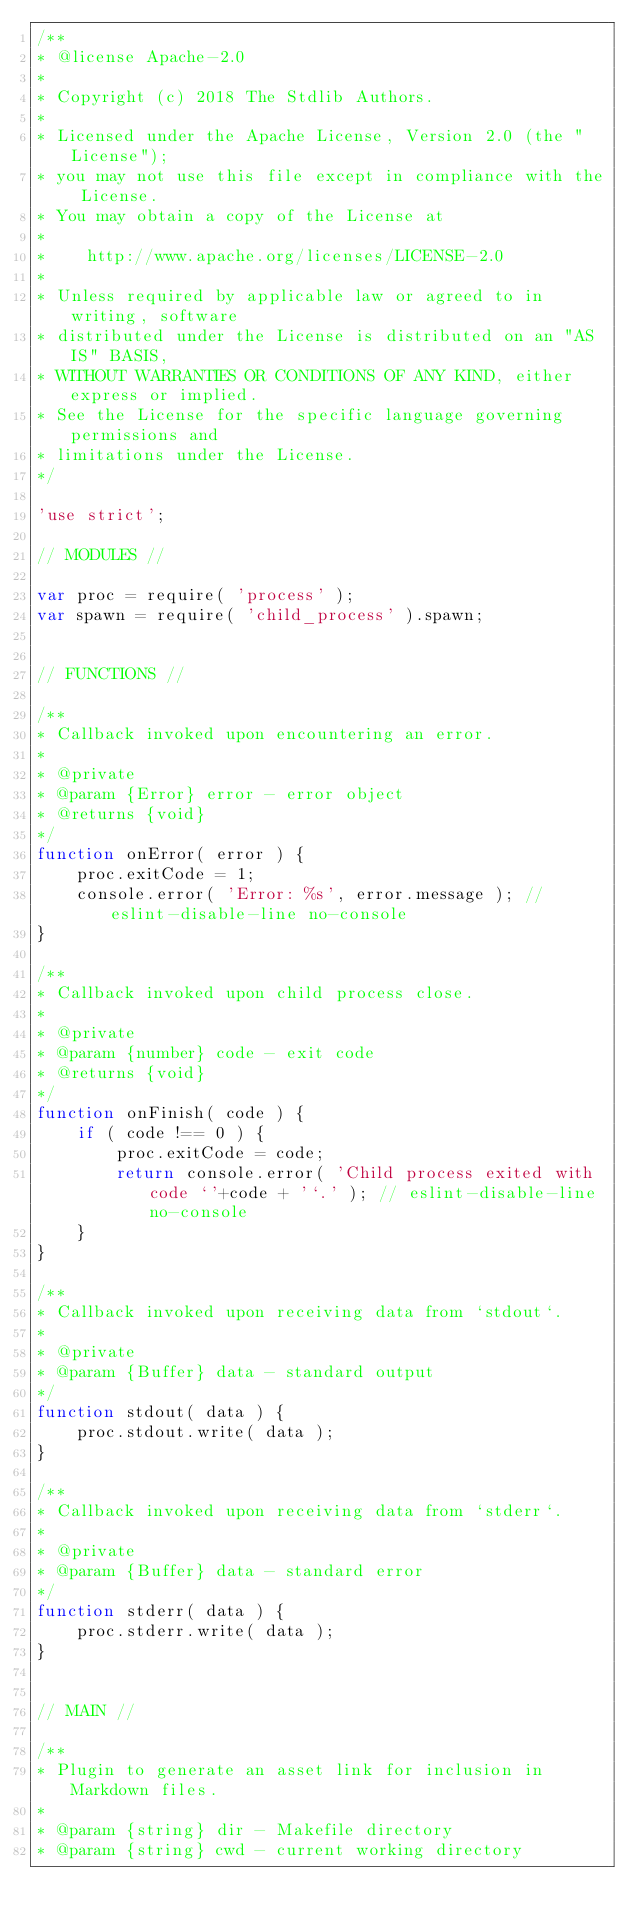<code> <loc_0><loc_0><loc_500><loc_500><_JavaScript_>/**
* @license Apache-2.0
*
* Copyright (c) 2018 The Stdlib Authors.
*
* Licensed under the Apache License, Version 2.0 (the "License");
* you may not use this file except in compliance with the License.
* You may obtain a copy of the License at
*
*    http://www.apache.org/licenses/LICENSE-2.0
*
* Unless required by applicable law or agreed to in writing, software
* distributed under the License is distributed on an "AS IS" BASIS,
* WITHOUT WARRANTIES OR CONDITIONS OF ANY KIND, either express or implied.
* See the License for the specific language governing permissions and
* limitations under the License.
*/

'use strict';

// MODULES //

var proc = require( 'process' );
var spawn = require( 'child_process' ).spawn;


// FUNCTIONS //

/**
* Callback invoked upon encountering an error.
*
* @private
* @param {Error} error - error object
* @returns {void}
*/
function onError( error ) {
	proc.exitCode = 1;
	console.error( 'Error: %s', error.message ); // eslint-disable-line no-console
}

/**
* Callback invoked upon child process close.
*
* @private
* @param {number} code - exit code
* @returns {void}
*/
function onFinish( code ) {
	if ( code !== 0 ) {
		proc.exitCode = code;
		return console.error( 'Child process exited with code `'+code + '`.' ); // eslint-disable-line no-console
	}
}

/**
* Callback invoked upon receiving data from `stdout`.
*
* @private
* @param {Buffer} data - standard output
*/
function stdout( data ) {
	proc.stdout.write( data );
}

/**
* Callback invoked upon receiving data from `stderr`.
*
* @private
* @param {Buffer} data - standard error
*/
function stderr( data ) {
	proc.stderr.write( data );
}


// MAIN //

/**
* Plugin to generate an asset link for inclusion in Markdown files.
*
* @param {string} dir - Makefile directory
* @param {string} cwd - current working directory</code> 